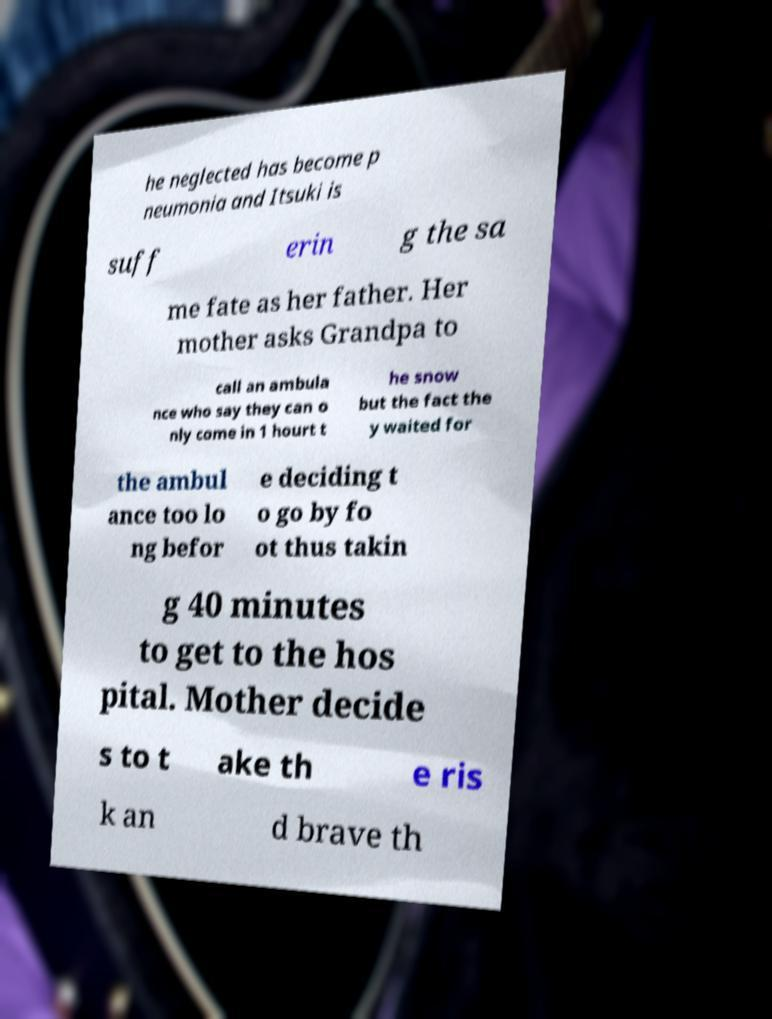For documentation purposes, I need the text within this image transcribed. Could you provide that? he neglected has become p neumonia and Itsuki is suff erin g the sa me fate as her father. Her mother asks Grandpa to call an ambula nce who say they can o nly come in 1 hourt t he snow but the fact the y waited for the ambul ance too lo ng befor e deciding t o go by fo ot thus takin g 40 minutes to get to the hos pital. Mother decide s to t ake th e ris k an d brave th 